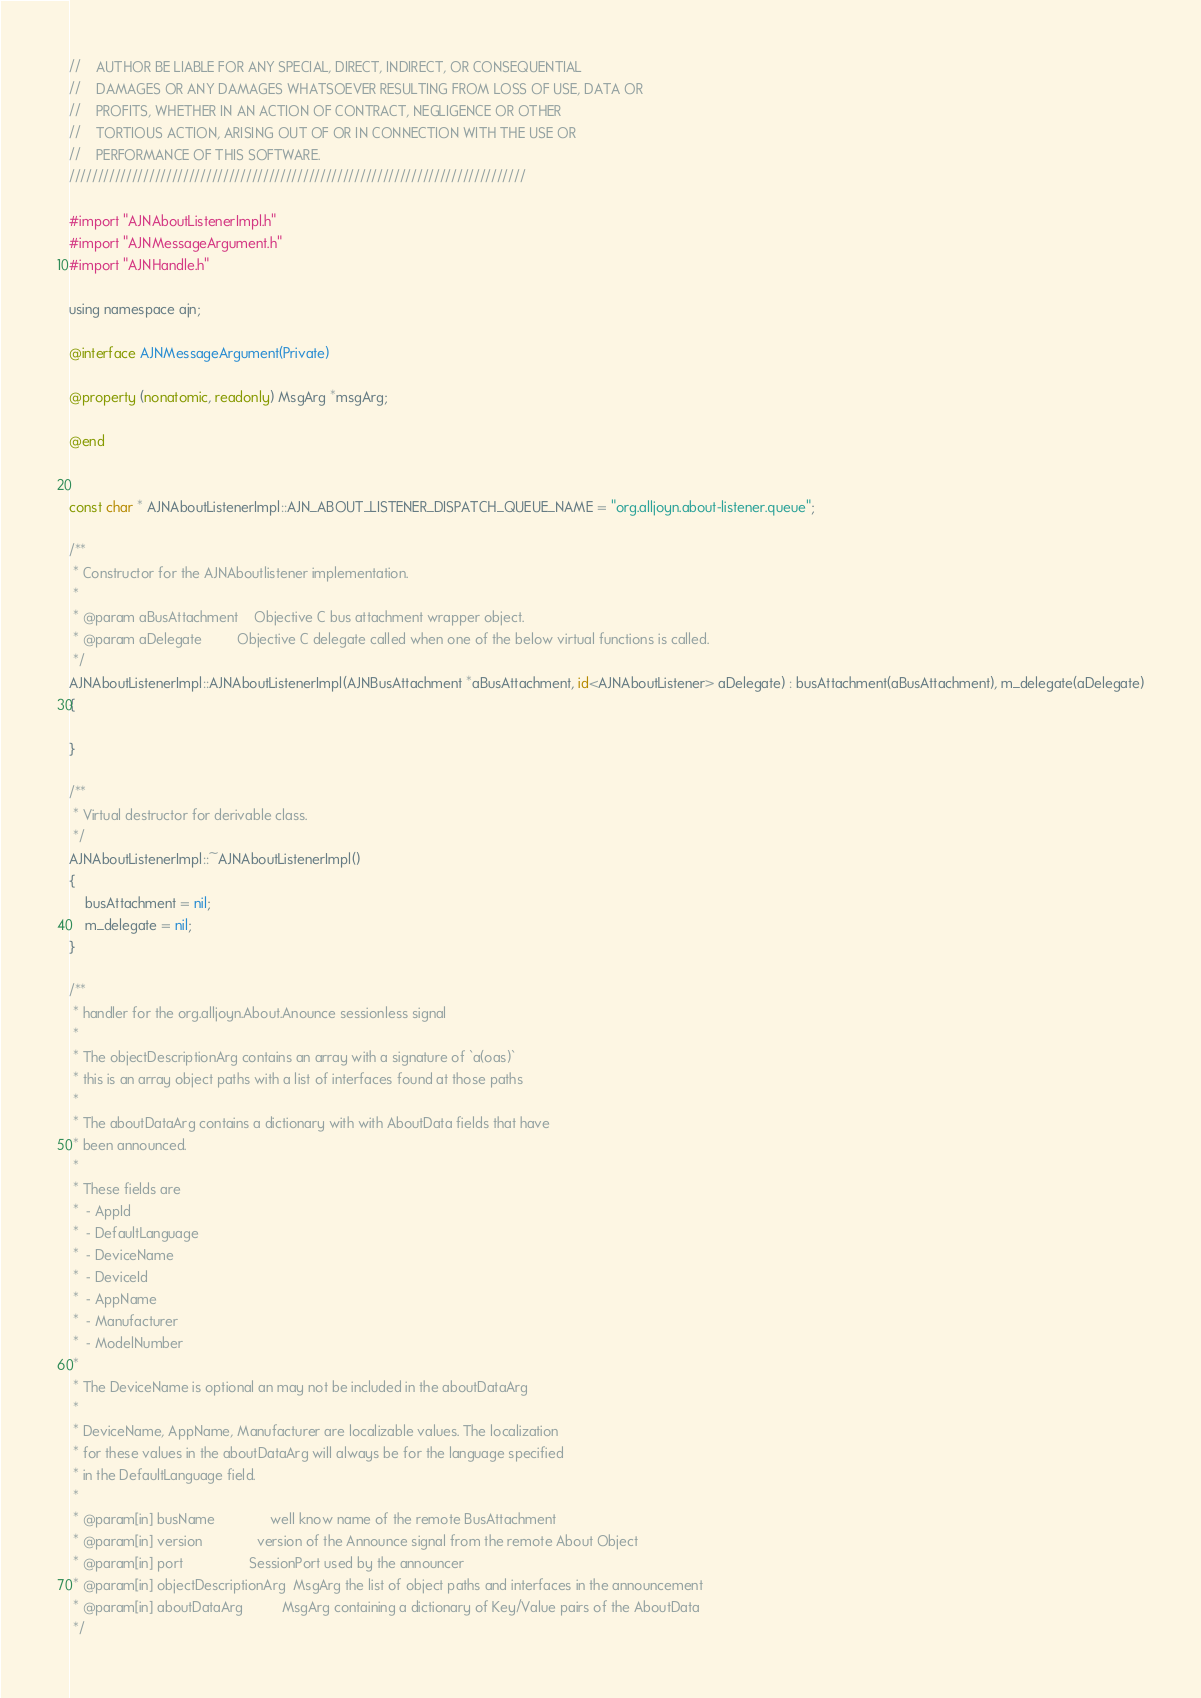Convert code to text. <code><loc_0><loc_0><loc_500><loc_500><_ObjectiveC_>//    AUTHOR BE LIABLE FOR ANY SPECIAL, DIRECT, INDIRECT, OR CONSEQUENTIAL
//    DAMAGES OR ANY DAMAGES WHATSOEVER RESULTING FROM LOSS OF USE, DATA OR
//    PROFITS, WHETHER IN AN ACTION OF CONTRACT, NEGLIGENCE OR OTHER
//    TORTIOUS ACTION, ARISING OUT OF OR IN CONNECTION WITH THE USE OR
//    PERFORMANCE OF THIS SOFTWARE.
////////////////////////////////////////////////////////////////////////////////

#import "AJNAboutListenerImpl.h"
#import "AJNMessageArgument.h"
#import "AJNHandle.h"

using namespace ajn;

@interface AJNMessageArgument(Private)

@property (nonatomic, readonly) MsgArg *msgArg;

@end


const char * AJNAboutListenerImpl::AJN_ABOUT_LISTENER_DISPATCH_QUEUE_NAME = "org.alljoyn.about-listener.queue";

/**
 * Constructor for the AJNAboutlistener implementation.
 *
 * @param aBusAttachment    Objective C bus attachment wrapper object.
 * @param aDelegate         Objective C delegate called when one of the below virtual functions is called.
 */
AJNAboutListenerImpl::AJNAboutListenerImpl(AJNBusAttachment *aBusAttachment, id<AJNAboutListener> aDelegate) : busAttachment(aBusAttachment), m_delegate(aDelegate)
{

}

/**
 * Virtual destructor for derivable class.
 */
AJNAboutListenerImpl::~AJNAboutListenerImpl()
{
    busAttachment = nil;
    m_delegate = nil;
}

/**
 * handler for the org.alljoyn.About.Anounce sessionless signal
 *
 * The objectDescriptionArg contains an array with a signature of `a(oas)`
 * this is an array object paths with a list of interfaces found at those paths
 *
 * The aboutDataArg contains a dictionary with with AboutData fields that have
 * been announced.
 *
 * These fields are
 *  - AppId
 *  - DefaultLanguage
 *  - DeviceName
 *  - DeviceId
 *  - AppName
 *  - Manufacturer
 *  - ModelNumber
 *
 * The DeviceName is optional an may not be included in the aboutDataArg
 *
 * DeviceName, AppName, Manufacturer are localizable values. The localization
 * for these values in the aboutDataArg will always be for the language specified
 * in the DefaultLanguage field.
 *
 * @param[in] busName              well know name of the remote BusAttachment
 * @param[in] version              version of the Announce signal from the remote About Object
 * @param[in] port                 SessionPort used by the announcer
 * @param[in] objectDescriptionArg  MsgArg the list of object paths and interfaces in the announcement
 * @param[in] aboutDataArg          MsgArg containing a dictionary of Key/Value pairs of the AboutData
 */
</code> 